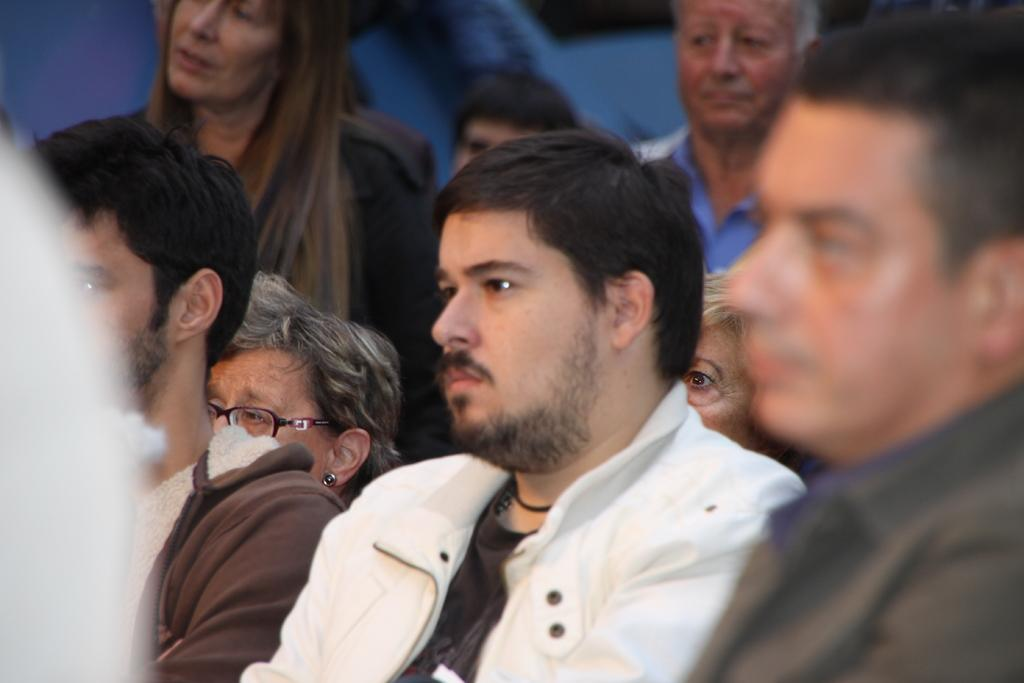What is the main subject of the image? The main subject of the image is a group of people. Can you describe the background of the image? The background of the image is blurred. How many eyes can be seen on the people in the image? There is no way to determine the number of eyes on the people in the image, as their faces are not clearly visible due to the blurred background. 